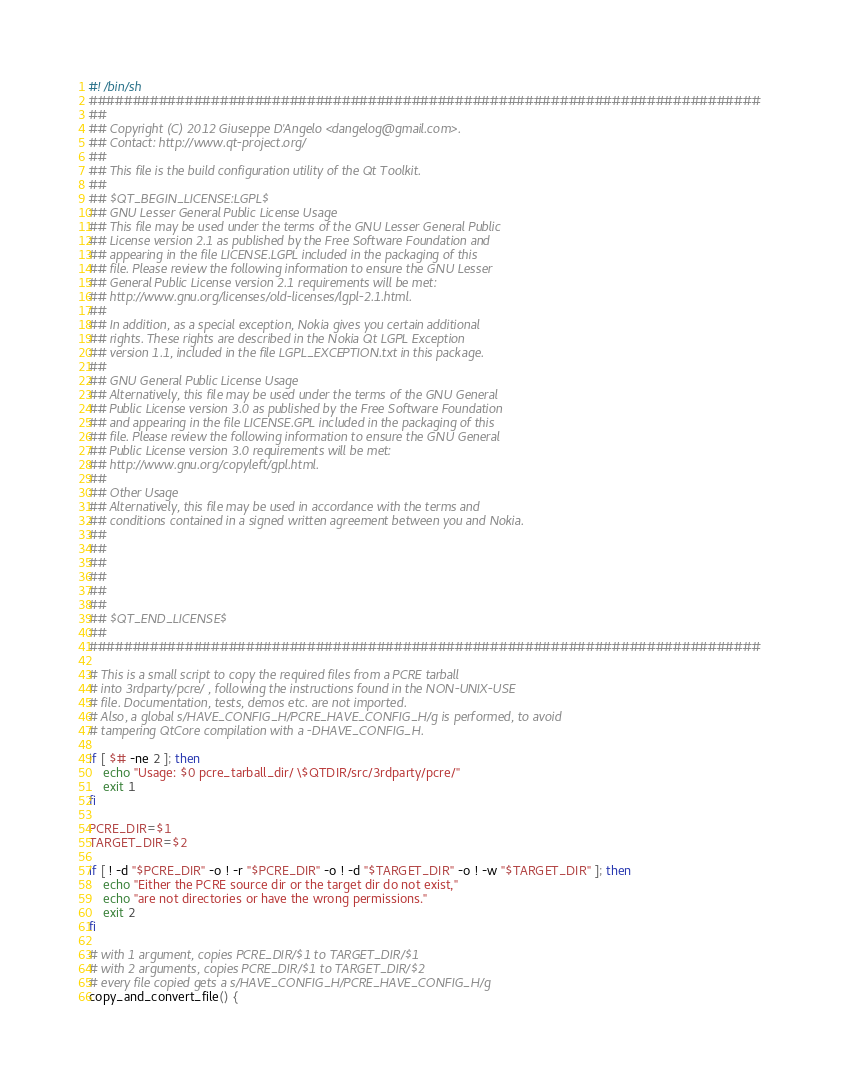<code> <loc_0><loc_0><loc_500><loc_500><_Bash_>#! /bin/sh
#############################################################################
##
## Copyright (C) 2012 Giuseppe D'Angelo <dangelog@gmail.com>.
## Contact: http://www.qt-project.org/
##
## This file is the build configuration utility of the Qt Toolkit.
##
## $QT_BEGIN_LICENSE:LGPL$
## GNU Lesser General Public License Usage
## This file may be used under the terms of the GNU Lesser General Public
## License version 2.1 as published by the Free Software Foundation and
## appearing in the file LICENSE.LGPL included in the packaging of this
## file. Please review the following information to ensure the GNU Lesser
## General Public License version 2.1 requirements will be met:
## http://www.gnu.org/licenses/old-licenses/lgpl-2.1.html.
##
## In addition, as a special exception, Nokia gives you certain additional
## rights. These rights are described in the Nokia Qt LGPL Exception
## version 1.1, included in the file LGPL_EXCEPTION.txt in this package.
##
## GNU General Public License Usage
## Alternatively, this file may be used under the terms of the GNU General
## Public License version 3.0 as published by the Free Software Foundation
## and appearing in the file LICENSE.GPL included in the packaging of this
## file. Please review the following information to ensure the GNU General
## Public License version 3.0 requirements will be met:
## http://www.gnu.org/copyleft/gpl.html.
##
## Other Usage
## Alternatively, this file may be used in accordance with the terms and
## conditions contained in a signed written agreement between you and Nokia.
##
##
##
##
##
##
## $QT_END_LICENSE$
##
#############################################################################

# This is a small script to copy the required files from a PCRE tarball
# into 3rdparty/pcre/ , following the instructions found in the NON-UNIX-USE
# file. Documentation, tests, demos etc. are not imported.
# Also, a global s/HAVE_CONFIG_H/PCRE_HAVE_CONFIG_H/g is performed, to avoid
# tampering QtCore compilation with a -DHAVE_CONFIG_H.

if [ $# -ne 2 ]; then
    echo "Usage: $0 pcre_tarball_dir/ \$QTDIR/src/3rdparty/pcre/"
    exit 1
fi

PCRE_DIR=$1
TARGET_DIR=$2

if [ ! -d "$PCRE_DIR" -o ! -r "$PCRE_DIR" -o ! -d "$TARGET_DIR" -o ! -w "$TARGET_DIR" ]; then
    echo "Either the PCRE source dir or the target dir do not exist,"
    echo "are not directories or have the wrong permissions."
    exit 2
fi

# with 1 argument, copies PCRE_DIR/$1 to TARGET_DIR/$1
# with 2 arguments, copies PCRE_DIR/$1 to TARGET_DIR/$2
# every file copied gets a s/HAVE_CONFIG_H/PCRE_HAVE_CONFIG_H/g
copy_and_convert_file() {</code> 